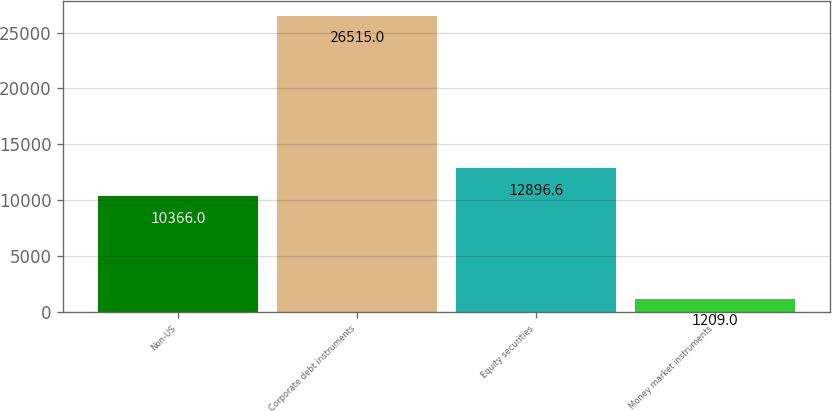<chart> <loc_0><loc_0><loc_500><loc_500><bar_chart><fcel>Non-US<fcel>Corporate debt instruments<fcel>Equity securities<fcel>Money market instruments<nl><fcel>10366<fcel>26515<fcel>12896.6<fcel>1209<nl></chart> 